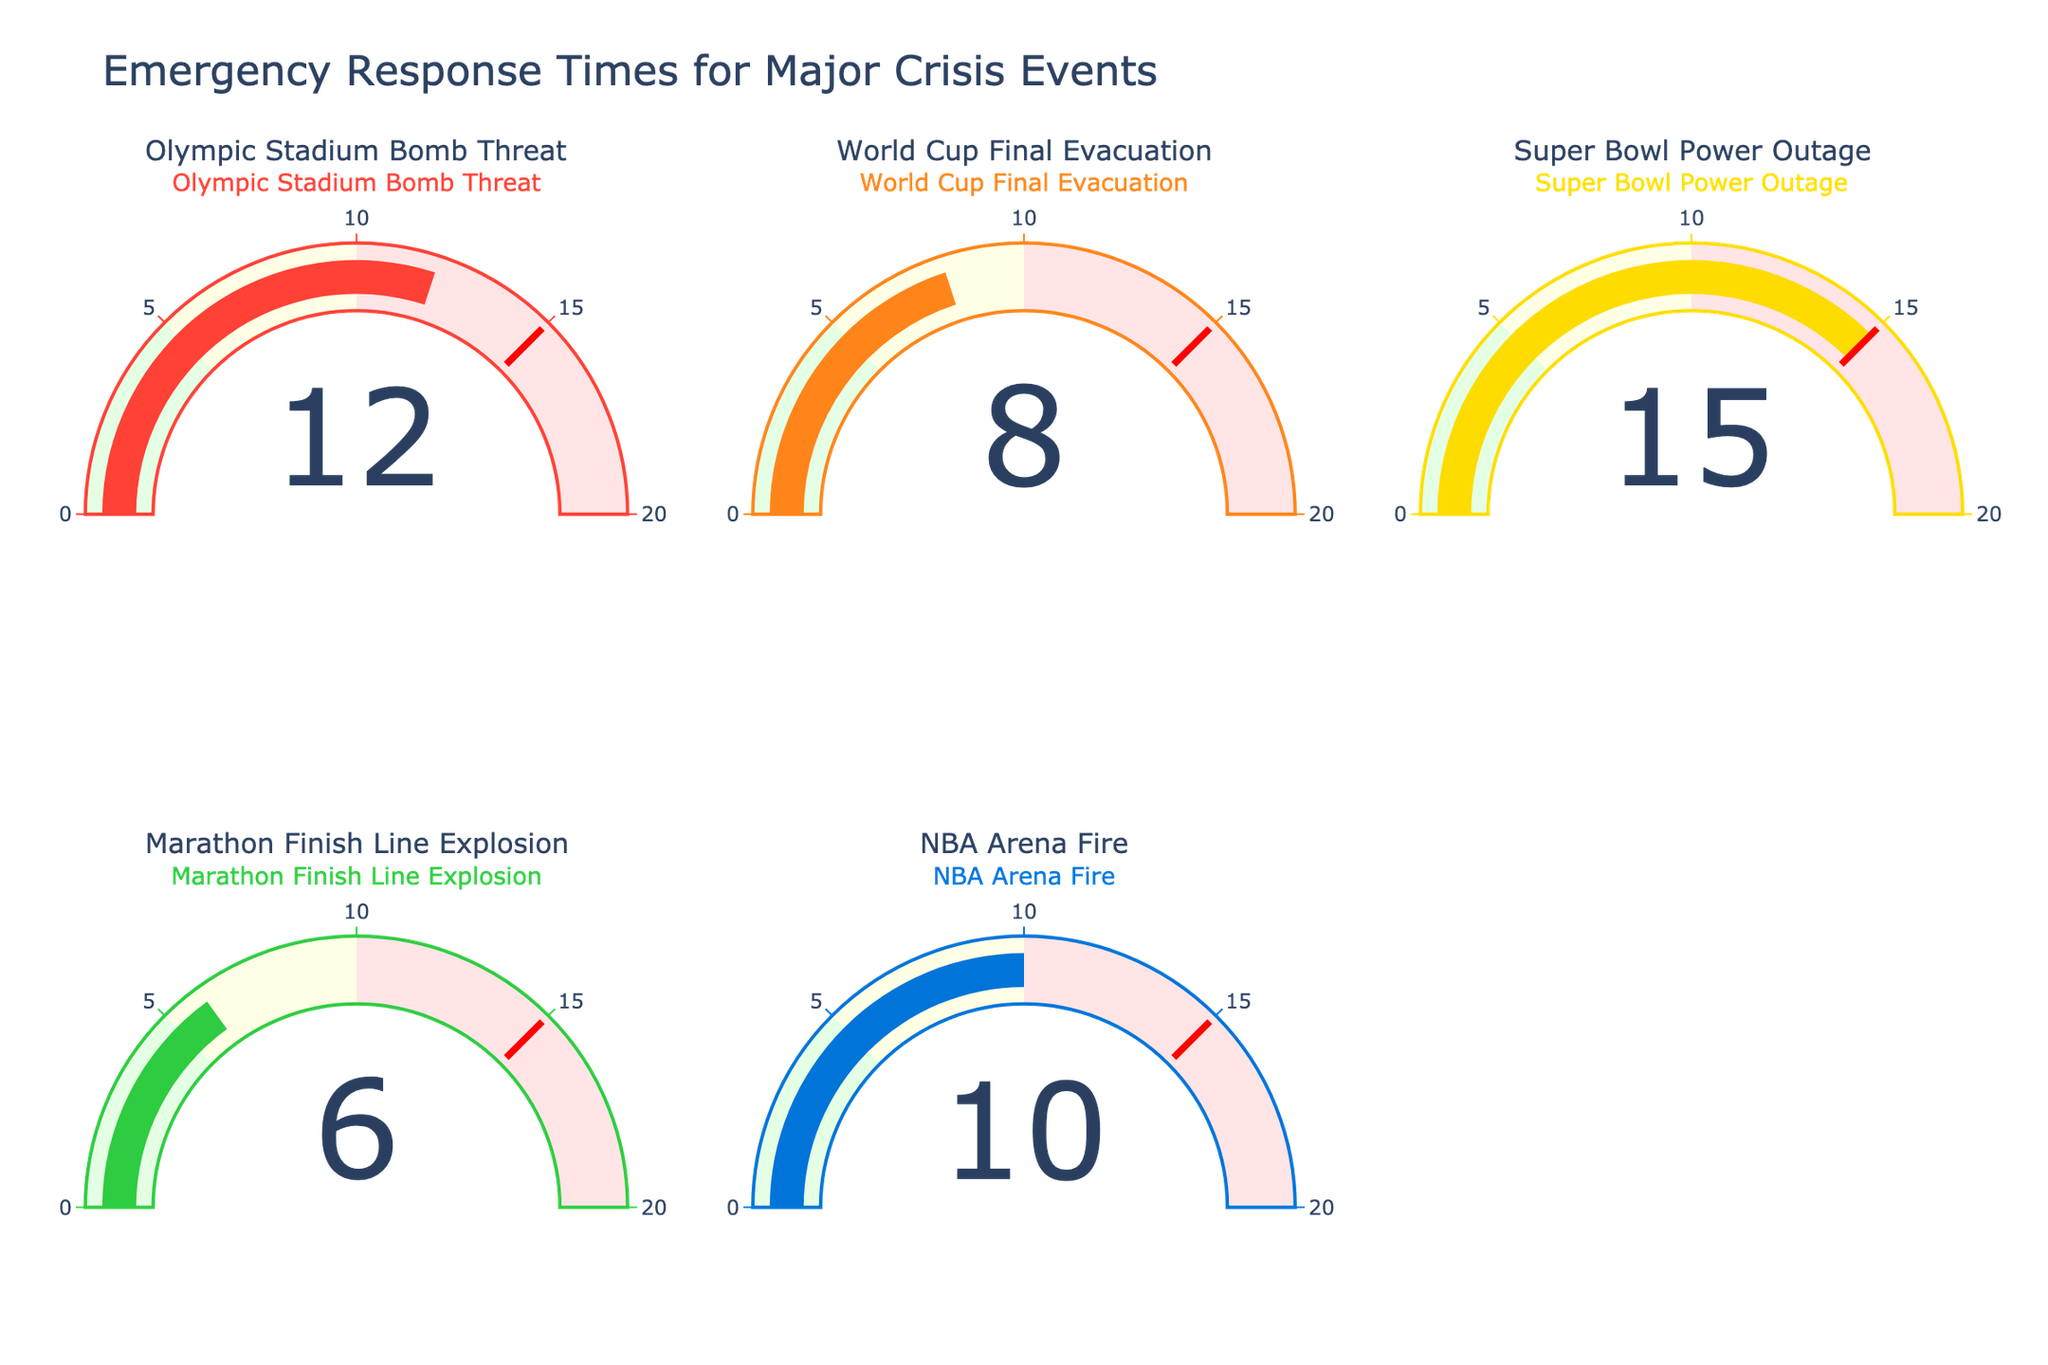Which event had the fastest emergency response time? The Marathon Finish Line Explosion gauge shows the value as 6 minutes, the lowest among all events displayed.
Answer: Marathon Finish Line Explosion Which event had the slowest emergency response time? The Super Bowl Power Outage gauge shows the value as 15 minutes, the highest among all events displayed.
Answer: Super Bowl Power Outage What's the difference in response time between the Olympic Stadium Bomb Threat and the NBA Arena Fire? The Olympic Stadium Bomb Threat has a response time of 12 minutes, and the NBA Arena Fire has a response time of 10 minutes. The difference is 12 - 10 = 2 minutes.
Answer: 2 minutes What's the average emergency response time for the five events? Summing the response times (12 + 8 + 15 + 6 + 10) gives 51. The average is 51 / 5 = 10.2 minutes.
Answer: 10.2 minutes How many events had a response time less than 10 minutes? The events with response times less than 10 minutes are the World Cup Final Evacuation (8 minutes) and the Marathon Finish Line Explosion (6 minutes). There are 2 such events.
Answer: 2 Is the response time for the Super Bowl Power Outage within the highest range of the gauge chart? The highest range of the gauge chart is 10 to 20 minutes. The Super Bowl Power Outage has a response time of 15 minutes, which falls within this range.
Answer: Yes Which event took longer to respond to compared to the NBA Arena Fire? The NBA Arena Fire has a response time of 10 minutes. The Olympic Stadium Bomb Threat (12 minutes) and the Super Bowl Power Outage (15 minutes) took longer to respond to.
Answer: Olympic Stadium Bomb Threat and Super Bowl Power Outage What's the sum of the response times for events with response times greater than 10 minutes? The events with response times greater than 10 minutes are the Olympic Stadium Bomb Threat (12 minutes) and the Super Bowl Power Outage (15 minutes). The sum is 12 + 15 = 27 minutes.
Answer: 27 minutes How does the response time for the World Cup Final Evacuation compare to the Marathon Finish Line Explosion? The World Cup Final Evacuation has a response time of 8 minutes, while the Marathon Finish Line Explosion has a response time of 6 minutes. The World Cup Final Evacuation took 2 minutes longer.
Answer: World Cup Final Evacuation took 2 minutes longer 